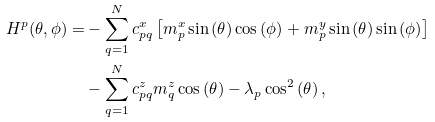<formula> <loc_0><loc_0><loc_500><loc_500>H ^ { p } ( \theta , \phi ) = & - \sum _ { q = 1 } ^ { N } c ^ { x } _ { p q } \left [ m ^ { x } _ { p } \sin { ( \theta ) } \cos { ( \phi ) } + m ^ { y } _ { p } \sin { ( \theta ) } \sin { ( \phi ) } \right ] \\ & - \sum _ { q = 1 } ^ { N } c ^ { z } _ { p q } m ^ { z } _ { q } \cos { ( \theta ) } - \lambda _ { p } \cos ^ { 2 } { ( \theta ) } \, ,</formula> 